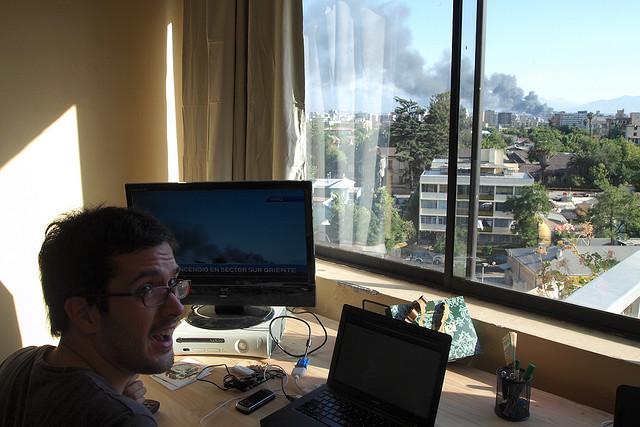What is the black smoke coming from?
Be succinct. Fire. How many electronic devices are on the table?
Quick response, please. 3. What has happened?
Keep it brief. Fire. 